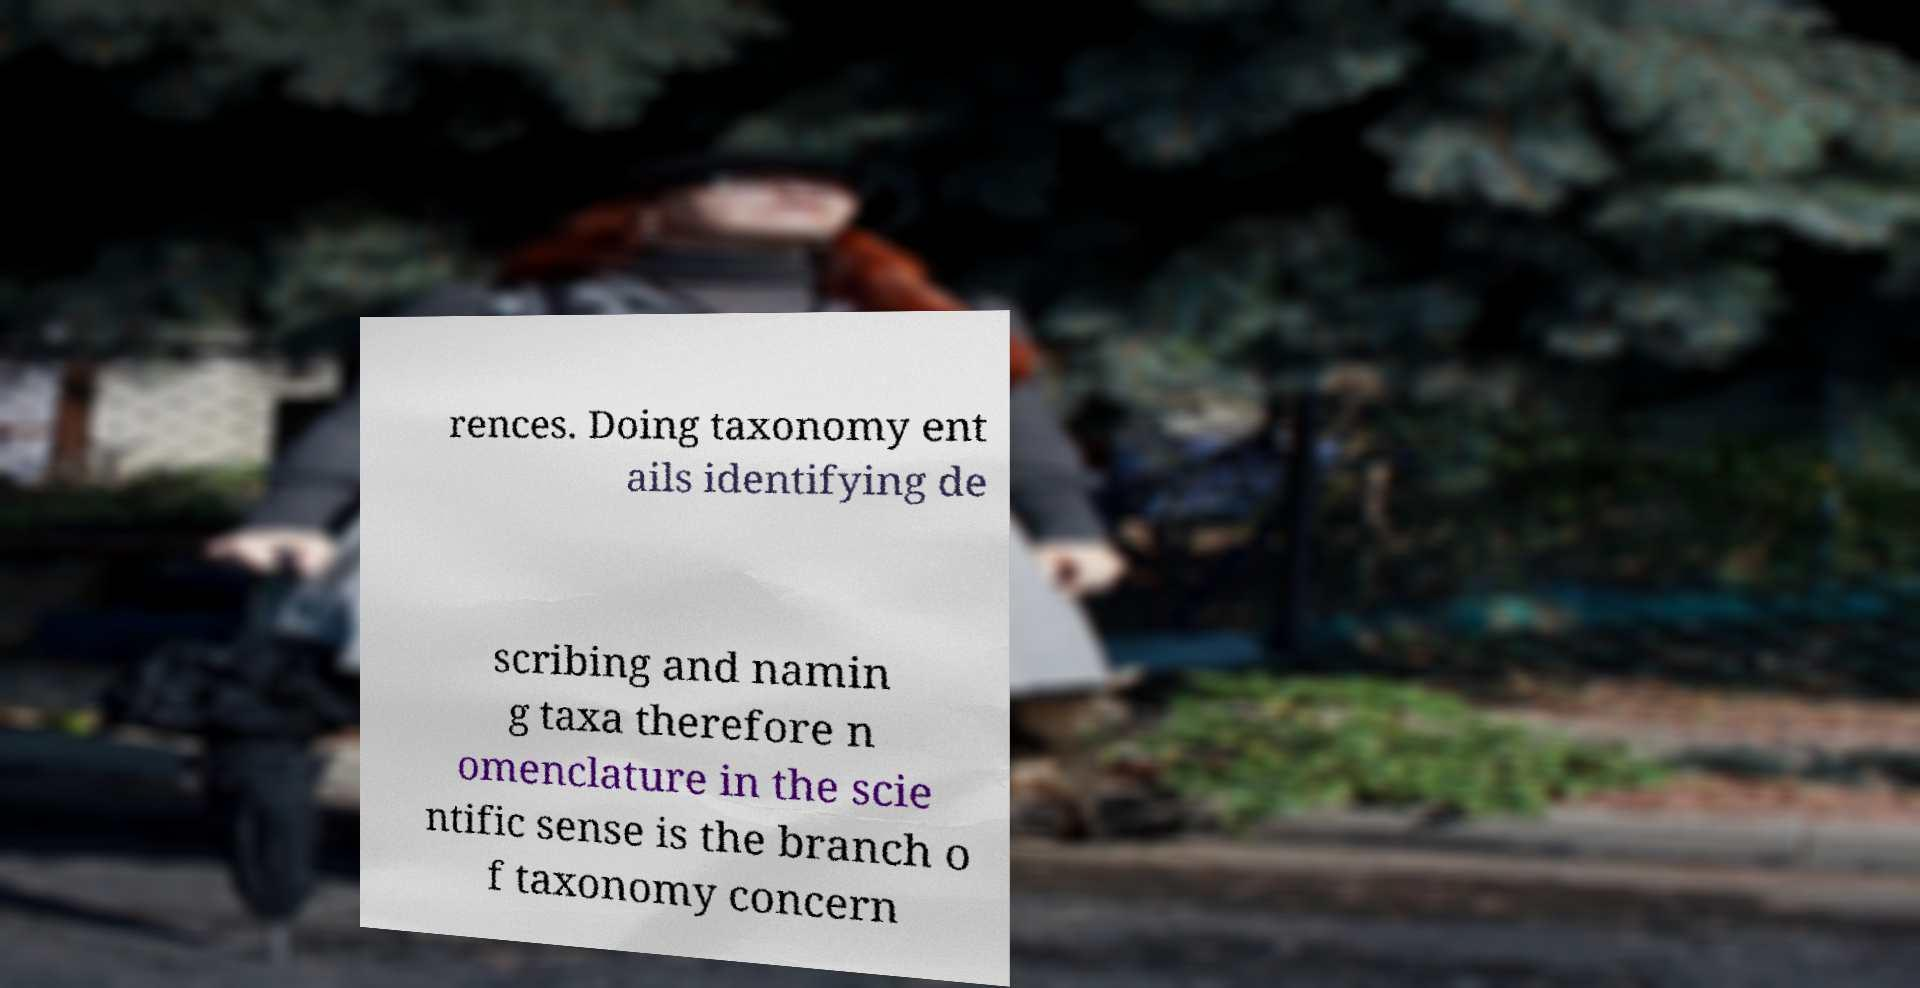There's text embedded in this image that I need extracted. Can you transcribe it verbatim? rences. Doing taxonomy ent ails identifying de scribing and namin g taxa therefore n omenclature in the scie ntific sense is the branch o f taxonomy concern 